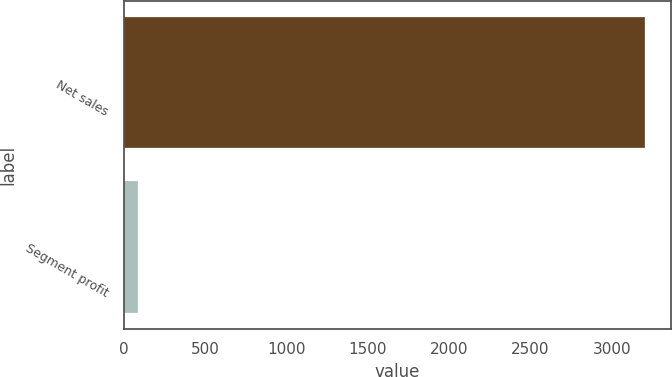Convert chart. <chart><loc_0><loc_0><loc_500><loc_500><bar_chart><fcel>Net sales<fcel>Segment profit<nl><fcel>3205<fcel>90<nl></chart> 